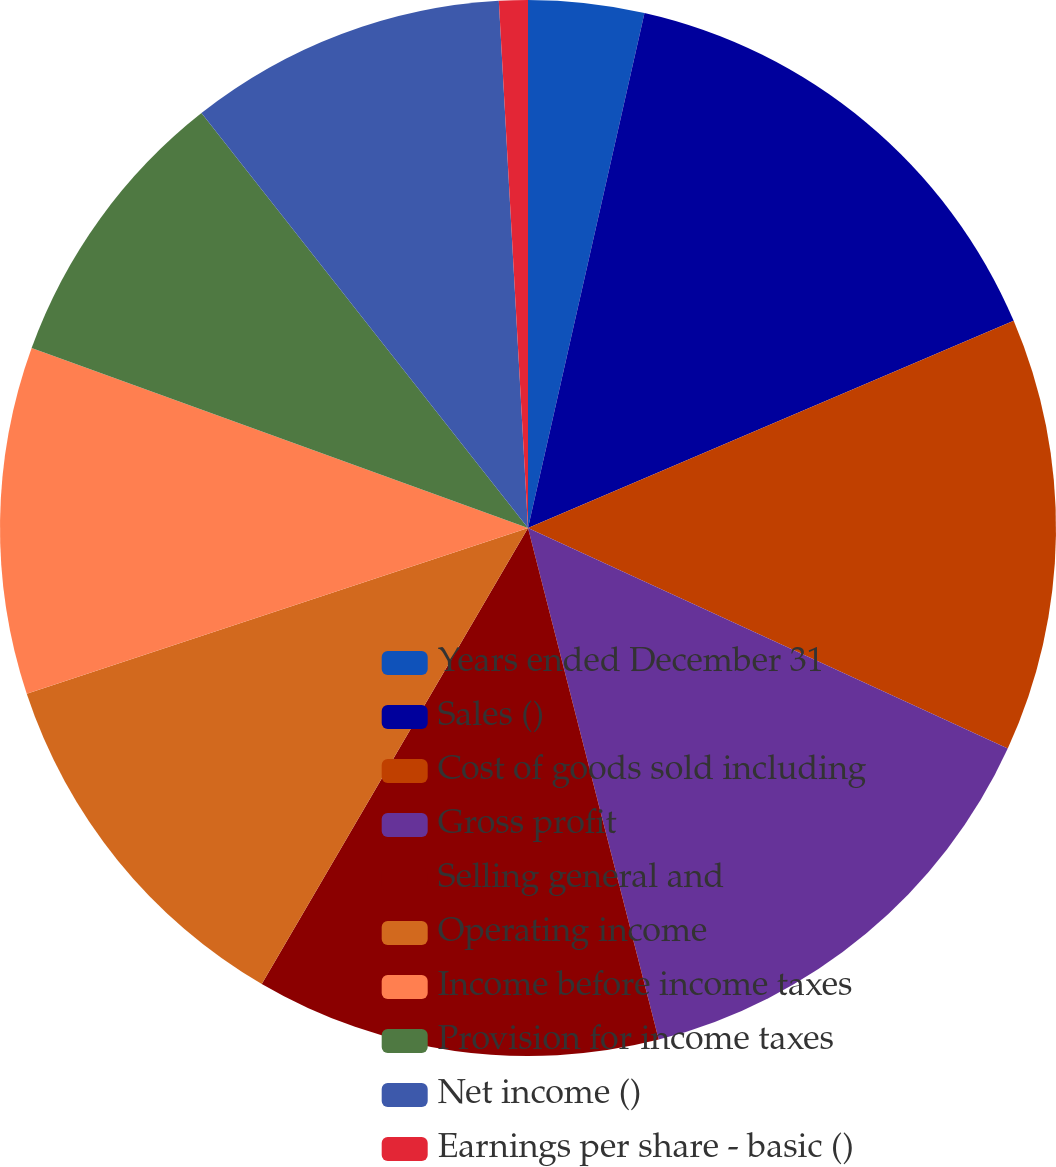<chart> <loc_0><loc_0><loc_500><loc_500><pie_chart><fcel>Years ended December 31<fcel>Sales ()<fcel>Cost of goods sold including<fcel>Gross profit<fcel>Selling general and<fcel>Operating income<fcel>Income before income taxes<fcel>Provision for income taxes<fcel>Net income ()<fcel>Earnings per share - basic ()<nl><fcel>3.54%<fcel>15.04%<fcel>13.27%<fcel>14.16%<fcel>12.39%<fcel>11.5%<fcel>10.62%<fcel>8.85%<fcel>9.73%<fcel>0.88%<nl></chart> 